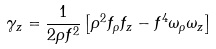<formula> <loc_0><loc_0><loc_500><loc_500>\gamma _ { z } = \frac { 1 } { 2 \rho f ^ { 2 } } \left [ \rho ^ { 2 } f _ { \rho } f _ { z } - f ^ { 4 } \omega _ { \rho } \omega _ { z } \right ]</formula> 